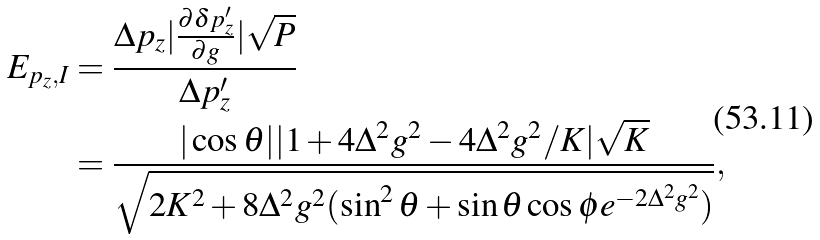Convert formula to latex. <formula><loc_0><loc_0><loc_500><loc_500>E _ { p _ { z } , I } & = \frac { \Delta p _ { z } | \frac { \partial \delta p ^ { \prime } _ { z } } { \partial g } | \sqrt { P } } { \Delta p _ { z } ^ { \prime } } \\ & = \frac { | \cos { \theta } | | 1 + 4 \Delta ^ { 2 } g ^ { 2 } - 4 \Delta ^ { 2 } g ^ { 2 } / K | \sqrt { K } } { \sqrt { 2 K ^ { 2 } + 8 \Delta ^ { 2 } g ^ { 2 } ( \sin ^ { 2 } { \theta } + \sin { \theta } \cos { \phi } e ^ { - 2 \Delta ^ { 2 } g ^ { 2 } } ) } } ,</formula> 